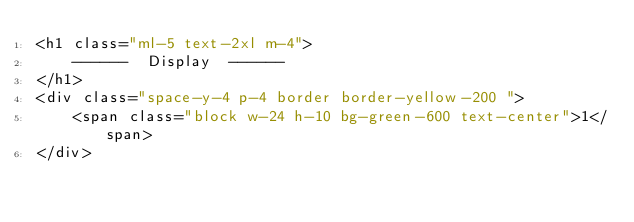<code> <loc_0><loc_0><loc_500><loc_500><_PHP_><h1 class="ml-5 text-2xl m-4">
    ------  Display  ------
</h1>
<div class="space-y-4 p-4 border border-yellow-200 ">
    <span class="block w-24 h-10 bg-green-600 text-center">1</span>
</div></code> 